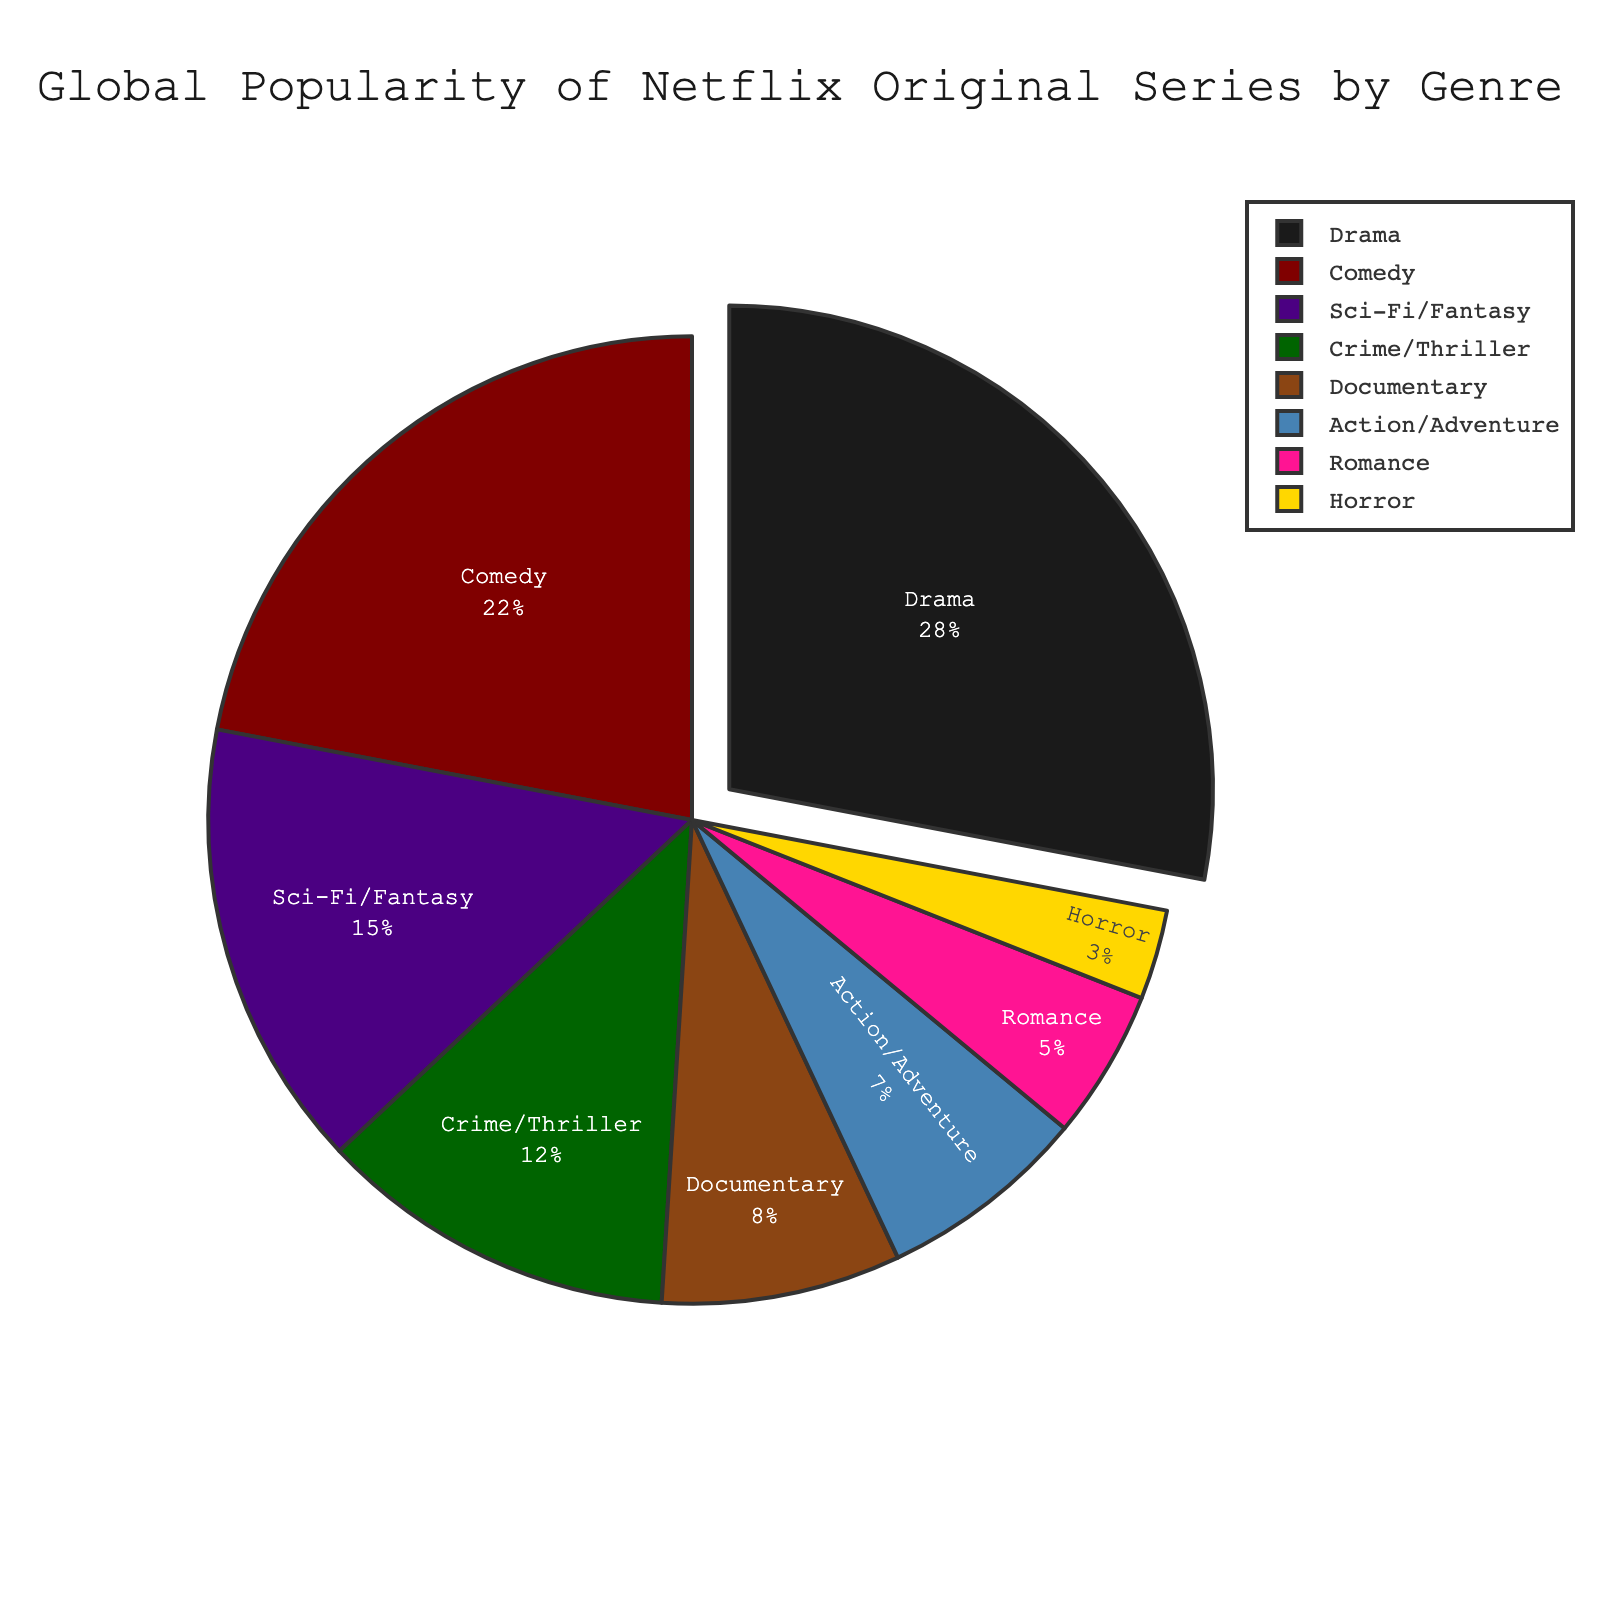What genre has the highest percentage of global popularity in Netflix original series? By looking at the pie chart, the largest slice can be identified which represents the highest percentage. The genre with the highest percentage is Drama.
Answer: Drama What is the combined percentage of Comedy and Romance genres? To find the combined percentage, add the individual percentages of Comedy (22%) and Romance (5%). This results in 22 + 5 = 27%.
Answer: 27% Which genre is more popular, Action/Adventure or Documentary, and by how much? Compare the percentages of Action/Adventure (7%) and Documentary (8%). Documentary is more popular by 1%.
Answer: Documentary, 1% What is the percentage difference between Sci-Fi/Fantasy and Horror genres? Subtract the percentage of Horror (3%) from the percentage of Sci-Fi/Fantasy (15%). This results in 15 - 3 = 12%.
Answer: 12% Which genre has the least global popularity percentage-wise? The smallest slice on the pie chart represents the genre with the least popularity. That genre is Horror.
Answer: Horror What is the total percentage of genres other than Drama? Subtract Drama's percentage (28%) from 100% to find the total percentage of the other genres: 100 - 28 = 72%.
Answer: 72% Are there more genres with a percentage below 10% or above 10%? Count the number of genres below 10% (Documentary, Action/Adventure, Romance, Horror: 4 genres) and compare it with the number of genres above 10% (Drama, Comedy, Sci-Fi/Fantasy, Crime/Thriller: 4 genres). Both have the same count.
Answer: Same count If you combined the Crime/Thriller and Horror genres, would the new percentage surpass that of Comedy? Add the percentages of Crime/Thriller (12%) and Horror (3%) to get 12 + 3 = 15%. Compare this with Comedy (22%). The new percentage would not surpass Comedy.
Answer: No Which slice of the pie is pulled out, and why? The pie chart typically pulls out the largest slice to draw attention to it. The largest slice, and thus the one pulled out, represents Drama genre.
Answer: Drama What genres make up over 50% of the total popularity together? To find genres making up over 50% combined, sum the percentages starting from the highest until exceeding 50%. Drama (28%) + Comedy (22%) = 50% exactly. Thus, Drama and Comedy together make up 50%.
Answer: Drama, Comedy 